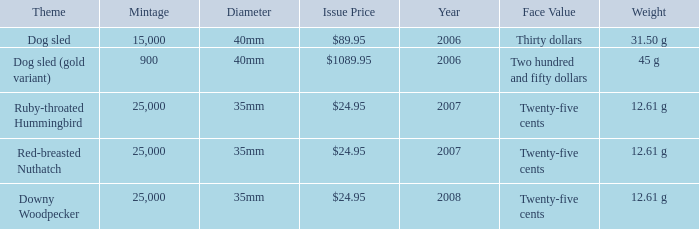What is the Diameter of the Dog Sled (gold variant) Theme coin? 40mm. 